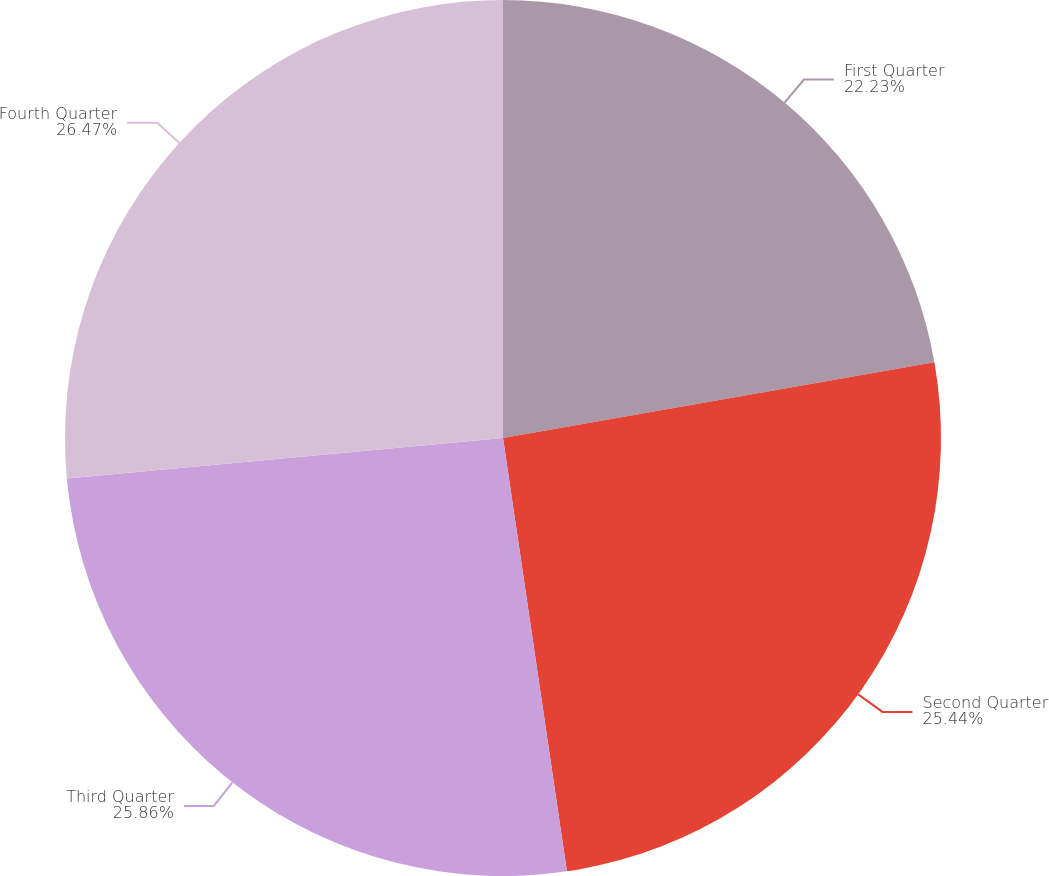Convert chart. <chart><loc_0><loc_0><loc_500><loc_500><pie_chart><fcel>First Quarter<fcel>Second Quarter<fcel>Third Quarter<fcel>Fourth Quarter<nl><fcel>22.23%<fcel>25.44%<fcel>25.86%<fcel>26.47%<nl></chart> 